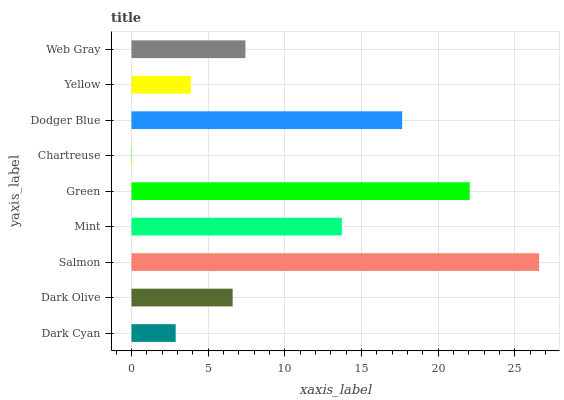Is Chartreuse the minimum?
Answer yes or no. Yes. Is Salmon the maximum?
Answer yes or no. Yes. Is Dark Olive the minimum?
Answer yes or no. No. Is Dark Olive the maximum?
Answer yes or no. No. Is Dark Olive greater than Dark Cyan?
Answer yes or no. Yes. Is Dark Cyan less than Dark Olive?
Answer yes or no. Yes. Is Dark Cyan greater than Dark Olive?
Answer yes or no. No. Is Dark Olive less than Dark Cyan?
Answer yes or no. No. Is Web Gray the high median?
Answer yes or no. Yes. Is Web Gray the low median?
Answer yes or no. Yes. Is Dark Cyan the high median?
Answer yes or no. No. Is Mint the low median?
Answer yes or no. No. 